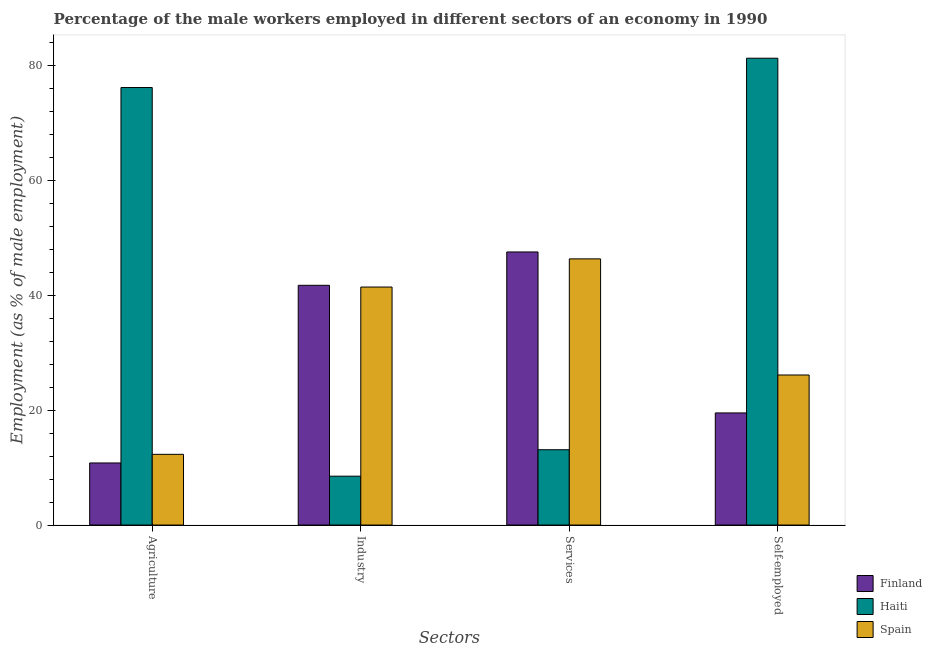How many groups of bars are there?
Give a very brief answer. 4. Are the number of bars per tick equal to the number of legend labels?
Offer a very short reply. Yes. Are the number of bars on each tick of the X-axis equal?
Provide a succinct answer. Yes. How many bars are there on the 3rd tick from the left?
Your response must be concise. 3. How many bars are there on the 3rd tick from the right?
Provide a succinct answer. 3. What is the label of the 2nd group of bars from the left?
Keep it short and to the point. Industry. What is the percentage of male workers in services in Finland?
Provide a short and direct response. 47.5. Across all countries, what is the maximum percentage of self employed male workers?
Your answer should be very brief. 81.2. Across all countries, what is the minimum percentage of male workers in agriculture?
Offer a very short reply. 10.8. In which country was the percentage of self employed male workers maximum?
Offer a terse response. Haiti. In which country was the percentage of male workers in services minimum?
Provide a short and direct response. Haiti. What is the total percentage of male workers in industry in the graph?
Provide a short and direct response. 91.6. What is the difference between the percentage of male workers in services in Haiti and that in Finland?
Your answer should be compact. -34.4. What is the difference between the percentage of male workers in industry in Spain and the percentage of self employed male workers in Haiti?
Offer a terse response. -39.8. What is the average percentage of male workers in agriculture per country?
Your response must be concise. 33.07. In how many countries, is the percentage of male workers in agriculture greater than 56 %?
Offer a very short reply. 1. What is the ratio of the percentage of self employed male workers in Finland to that in Haiti?
Provide a short and direct response. 0.24. Is the percentage of male workers in agriculture in Spain less than that in Finland?
Provide a succinct answer. No. What is the difference between the highest and the second highest percentage of male workers in industry?
Provide a short and direct response. 0.3. What is the difference between the highest and the lowest percentage of male workers in services?
Provide a succinct answer. 34.4. In how many countries, is the percentage of self employed male workers greater than the average percentage of self employed male workers taken over all countries?
Give a very brief answer. 1. What does the 2nd bar from the left in Industry represents?
Ensure brevity in your answer.  Haiti. What does the 2nd bar from the right in Self-employed represents?
Your answer should be very brief. Haiti. How many bars are there?
Provide a succinct answer. 12. Are all the bars in the graph horizontal?
Your response must be concise. No. Are the values on the major ticks of Y-axis written in scientific E-notation?
Make the answer very short. No. Does the graph contain any zero values?
Ensure brevity in your answer.  No. Where does the legend appear in the graph?
Keep it short and to the point. Bottom right. How many legend labels are there?
Keep it short and to the point. 3. How are the legend labels stacked?
Ensure brevity in your answer.  Vertical. What is the title of the graph?
Provide a short and direct response. Percentage of the male workers employed in different sectors of an economy in 1990. Does "European Union" appear as one of the legend labels in the graph?
Offer a terse response. No. What is the label or title of the X-axis?
Ensure brevity in your answer.  Sectors. What is the label or title of the Y-axis?
Offer a very short reply. Employment (as % of male employment). What is the Employment (as % of male employment) in Finland in Agriculture?
Your response must be concise. 10.8. What is the Employment (as % of male employment) in Haiti in Agriculture?
Offer a terse response. 76.1. What is the Employment (as % of male employment) in Spain in Agriculture?
Provide a succinct answer. 12.3. What is the Employment (as % of male employment) in Finland in Industry?
Provide a succinct answer. 41.7. What is the Employment (as % of male employment) in Haiti in Industry?
Offer a very short reply. 8.5. What is the Employment (as % of male employment) of Spain in Industry?
Your answer should be compact. 41.4. What is the Employment (as % of male employment) of Finland in Services?
Offer a very short reply. 47.5. What is the Employment (as % of male employment) in Haiti in Services?
Make the answer very short. 13.1. What is the Employment (as % of male employment) of Spain in Services?
Make the answer very short. 46.3. What is the Employment (as % of male employment) of Finland in Self-employed?
Provide a short and direct response. 19.5. What is the Employment (as % of male employment) of Haiti in Self-employed?
Offer a very short reply. 81.2. What is the Employment (as % of male employment) in Spain in Self-employed?
Offer a terse response. 26.1. Across all Sectors, what is the maximum Employment (as % of male employment) in Finland?
Provide a succinct answer. 47.5. Across all Sectors, what is the maximum Employment (as % of male employment) of Haiti?
Your answer should be very brief. 81.2. Across all Sectors, what is the maximum Employment (as % of male employment) of Spain?
Offer a very short reply. 46.3. Across all Sectors, what is the minimum Employment (as % of male employment) in Finland?
Provide a short and direct response. 10.8. Across all Sectors, what is the minimum Employment (as % of male employment) of Spain?
Provide a succinct answer. 12.3. What is the total Employment (as % of male employment) in Finland in the graph?
Keep it short and to the point. 119.5. What is the total Employment (as % of male employment) in Haiti in the graph?
Your response must be concise. 178.9. What is the total Employment (as % of male employment) in Spain in the graph?
Your response must be concise. 126.1. What is the difference between the Employment (as % of male employment) of Finland in Agriculture and that in Industry?
Offer a terse response. -30.9. What is the difference between the Employment (as % of male employment) in Haiti in Agriculture and that in Industry?
Offer a very short reply. 67.6. What is the difference between the Employment (as % of male employment) in Spain in Agriculture and that in Industry?
Offer a very short reply. -29.1. What is the difference between the Employment (as % of male employment) of Finland in Agriculture and that in Services?
Offer a terse response. -36.7. What is the difference between the Employment (as % of male employment) in Spain in Agriculture and that in Services?
Keep it short and to the point. -34. What is the difference between the Employment (as % of male employment) in Finland in Agriculture and that in Self-employed?
Offer a terse response. -8.7. What is the difference between the Employment (as % of male employment) in Haiti in Agriculture and that in Self-employed?
Provide a succinct answer. -5.1. What is the difference between the Employment (as % of male employment) in Spain in Industry and that in Services?
Provide a succinct answer. -4.9. What is the difference between the Employment (as % of male employment) of Finland in Industry and that in Self-employed?
Offer a very short reply. 22.2. What is the difference between the Employment (as % of male employment) in Haiti in Industry and that in Self-employed?
Provide a succinct answer. -72.7. What is the difference between the Employment (as % of male employment) of Spain in Industry and that in Self-employed?
Provide a short and direct response. 15.3. What is the difference between the Employment (as % of male employment) in Haiti in Services and that in Self-employed?
Offer a very short reply. -68.1. What is the difference between the Employment (as % of male employment) of Spain in Services and that in Self-employed?
Offer a very short reply. 20.2. What is the difference between the Employment (as % of male employment) of Finland in Agriculture and the Employment (as % of male employment) of Haiti in Industry?
Your answer should be very brief. 2.3. What is the difference between the Employment (as % of male employment) in Finland in Agriculture and the Employment (as % of male employment) in Spain in Industry?
Offer a terse response. -30.6. What is the difference between the Employment (as % of male employment) of Haiti in Agriculture and the Employment (as % of male employment) of Spain in Industry?
Make the answer very short. 34.7. What is the difference between the Employment (as % of male employment) of Finland in Agriculture and the Employment (as % of male employment) of Haiti in Services?
Give a very brief answer. -2.3. What is the difference between the Employment (as % of male employment) of Finland in Agriculture and the Employment (as % of male employment) of Spain in Services?
Provide a succinct answer. -35.5. What is the difference between the Employment (as % of male employment) of Haiti in Agriculture and the Employment (as % of male employment) of Spain in Services?
Offer a terse response. 29.8. What is the difference between the Employment (as % of male employment) of Finland in Agriculture and the Employment (as % of male employment) of Haiti in Self-employed?
Provide a short and direct response. -70.4. What is the difference between the Employment (as % of male employment) in Finland in Agriculture and the Employment (as % of male employment) in Spain in Self-employed?
Offer a terse response. -15.3. What is the difference between the Employment (as % of male employment) of Haiti in Agriculture and the Employment (as % of male employment) of Spain in Self-employed?
Provide a short and direct response. 50. What is the difference between the Employment (as % of male employment) of Finland in Industry and the Employment (as % of male employment) of Haiti in Services?
Offer a terse response. 28.6. What is the difference between the Employment (as % of male employment) of Haiti in Industry and the Employment (as % of male employment) of Spain in Services?
Make the answer very short. -37.8. What is the difference between the Employment (as % of male employment) of Finland in Industry and the Employment (as % of male employment) of Haiti in Self-employed?
Keep it short and to the point. -39.5. What is the difference between the Employment (as % of male employment) of Haiti in Industry and the Employment (as % of male employment) of Spain in Self-employed?
Provide a succinct answer. -17.6. What is the difference between the Employment (as % of male employment) of Finland in Services and the Employment (as % of male employment) of Haiti in Self-employed?
Provide a succinct answer. -33.7. What is the difference between the Employment (as % of male employment) of Finland in Services and the Employment (as % of male employment) of Spain in Self-employed?
Give a very brief answer. 21.4. What is the difference between the Employment (as % of male employment) in Haiti in Services and the Employment (as % of male employment) in Spain in Self-employed?
Keep it short and to the point. -13. What is the average Employment (as % of male employment) in Finland per Sectors?
Make the answer very short. 29.88. What is the average Employment (as % of male employment) in Haiti per Sectors?
Your answer should be compact. 44.73. What is the average Employment (as % of male employment) in Spain per Sectors?
Make the answer very short. 31.52. What is the difference between the Employment (as % of male employment) of Finland and Employment (as % of male employment) of Haiti in Agriculture?
Provide a short and direct response. -65.3. What is the difference between the Employment (as % of male employment) of Finland and Employment (as % of male employment) of Spain in Agriculture?
Keep it short and to the point. -1.5. What is the difference between the Employment (as % of male employment) in Haiti and Employment (as % of male employment) in Spain in Agriculture?
Your response must be concise. 63.8. What is the difference between the Employment (as % of male employment) of Finland and Employment (as % of male employment) of Haiti in Industry?
Your response must be concise. 33.2. What is the difference between the Employment (as % of male employment) of Finland and Employment (as % of male employment) of Spain in Industry?
Give a very brief answer. 0.3. What is the difference between the Employment (as % of male employment) in Haiti and Employment (as % of male employment) in Spain in Industry?
Make the answer very short. -32.9. What is the difference between the Employment (as % of male employment) in Finland and Employment (as % of male employment) in Haiti in Services?
Give a very brief answer. 34.4. What is the difference between the Employment (as % of male employment) in Finland and Employment (as % of male employment) in Spain in Services?
Provide a short and direct response. 1.2. What is the difference between the Employment (as % of male employment) of Haiti and Employment (as % of male employment) of Spain in Services?
Your answer should be compact. -33.2. What is the difference between the Employment (as % of male employment) in Finland and Employment (as % of male employment) in Haiti in Self-employed?
Ensure brevity in your answer.  -61.7. What is the difference between the Employment (as % of male employment) in Finland and Employment (as % of male employment) in Spain in Self-employed?
Offer a terse response. -6.6. What is the difference between the Employment (as % of male employment) of Haiti and Employment (as % of male employment) of Spain in Self-employed?
Provide a succinct answer. 55.1. What is the ratio of the Employment (as % of male employment) in Finland in Agriculture to that in Industry?
Your answer should be very brief. 0.26. What is the ratio of the Employment (as % of male employment) of Haiti in Agriculture to that in Industry?
Ensure brevity in your answer.  8.95. What is the ratio of the Employment (as % of male employment) of Spain in Agriculture to that in Industry?
Your response must be concise. 0.3. What is the ratio of the Employment (as % of male employment) in Finland in Agriculture to that in Services?
Provide a succinct answer. 0.23. What is the ratio of the Employment (as % of male employment) of Haiti in Agriculture to that in Services?
Make the answer very short. 5.81. What is the ratio of the Employment (as % of male employment) of Spain in Agriculture to that in Services?
Your answer should be very brief. 0.27. What is the ratio of the Employment (as % of male employment) of Finland in Agriculture to that in Self-employed?
Offer a terse response. 0.55. What is the ratio of the Employment (as % of male employment) in Haiti in Agriculture to that in Self-employed?
Your answer should be compact. 0.94. What is the ratio of the Employment (as % of male employment) in Spain in Agriculture to that in Self-employed?
Your response must be concise. 0.47. What is the ratio of the Employment (as % of male employment) in Finland in Industry to that in Services?
Make the answer very short. 0.88. What is the ratio of the Employment (as % of male employment) of Haiti in Industry to that in Services?
Your response must be concise. 0.65. What is the ratio of the Employment (as % of male employment) of Spain in Industry to that in Services?
Provide a succinct answer. 0.89. What is the ratio of the Employment (as % of male employment) of Finland in Industry to that in Self-employed?
Your answer should be very brief. 2.14. What is the ratio of the Employment (as % of male employment) in Haiti in Industry to that in Self-employed?
Provide a short and direct response. 0.1. What is the ratio of the Employment (as % of male employment) in Spain in Industry to that in Self-employed?
Your response must be concise. 1.59. What is the ratio of the Employment (as % of male employment) in Finland in Services to that in Self-employed?
Your answer should be compact. 2.44. What is the ratio of the Employment (as % of male employment) of Haiti in Services to that in Self-employed?
Provide a succinct answer. 0.16. What is the ratio of the Employment (as % of male employment) in Spain in Services to that in Self-employed?
Offer a terse response. 1.77. What is the difference between the highest and the second highest Employment (as % of male employment) in Finland?
Make the answer very short. 5.8. What is the difference between the highest and the second highest Employment (as % of male employment) of Haiti?
Ensure brevity in your answer.  5.1. What is the difference between the highest and the second highest Employment (as % of male employment) of Spain?
Give a very brief answer. 4.9. What is the difference between the highest and the lowest Employment (as % of male employment) of Finland?
Ensure brevity in your answer.  36.7. What is the difference between the highest and the lowest Employment (as % of male employment) of Haiti?
Provide a succinct answer. 72.7. What is the difference between the highest and the lowest Employment (as % of male employment) in Spain?
Provide a short and direct response. 34. 